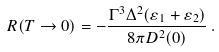Convert formula to latex. <formula><loc_0><loc_0><loc_500><loc_500>R ( T \to 0 ) = - \frac { \Gamma ^ { 3 } \Delta ^ { 2 } ( \varepsilon _ { 1 } + \varepsilon _ { 2 } ) } { 8 \pi D ^ { 2 } ( 0 ) } \, .</formula> 